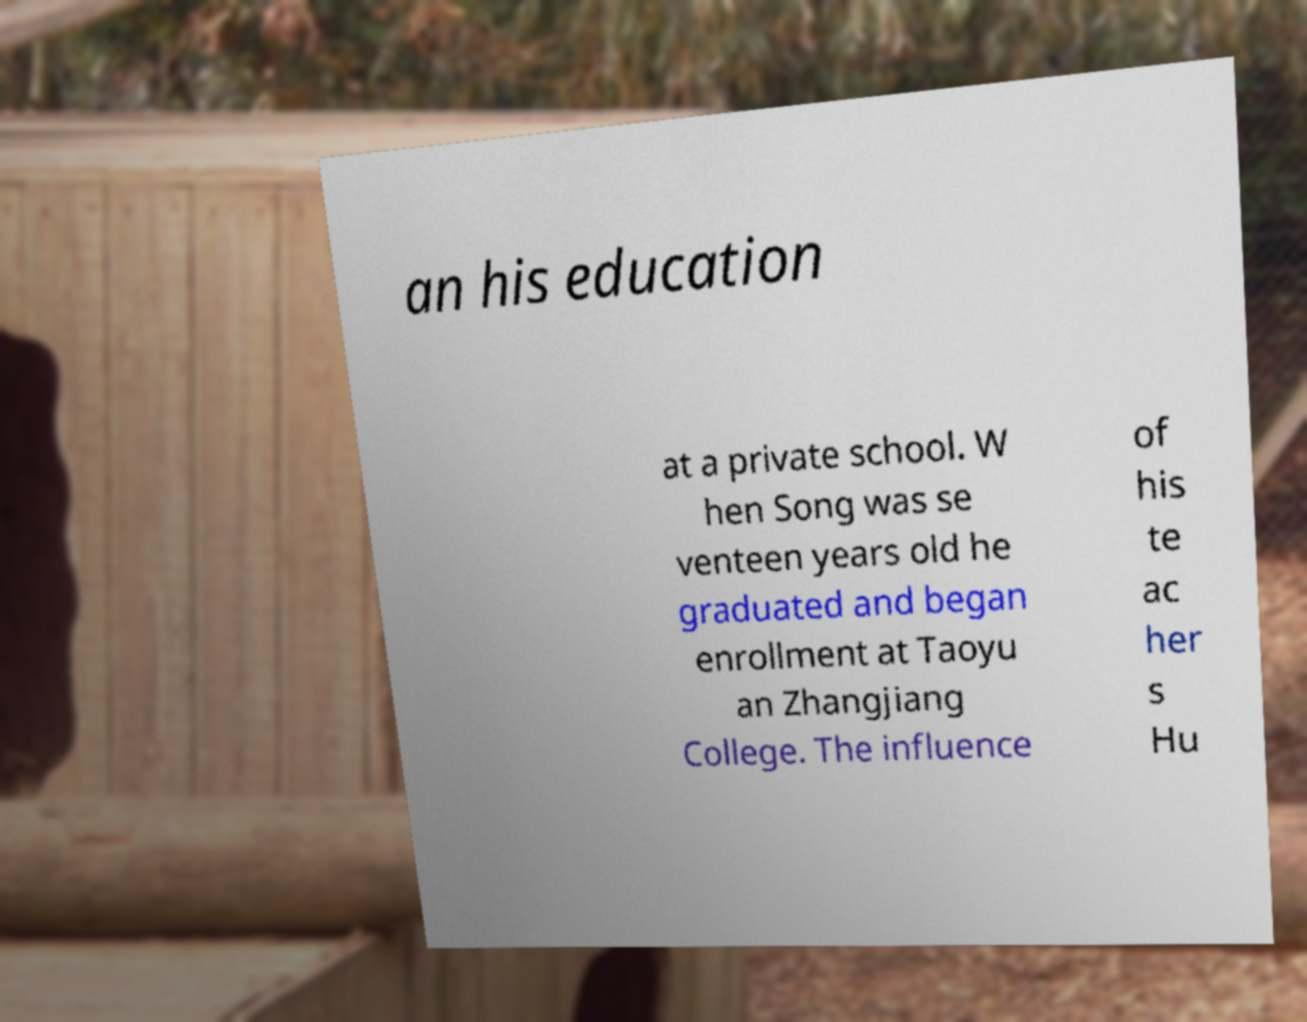Could you extract and type out the text from this image? an his education at a private school. W hen Song was se venteen years old he graduated and began enrollment at Taoyu an Zhangjiang College. The influence of his te ac her s Hu 